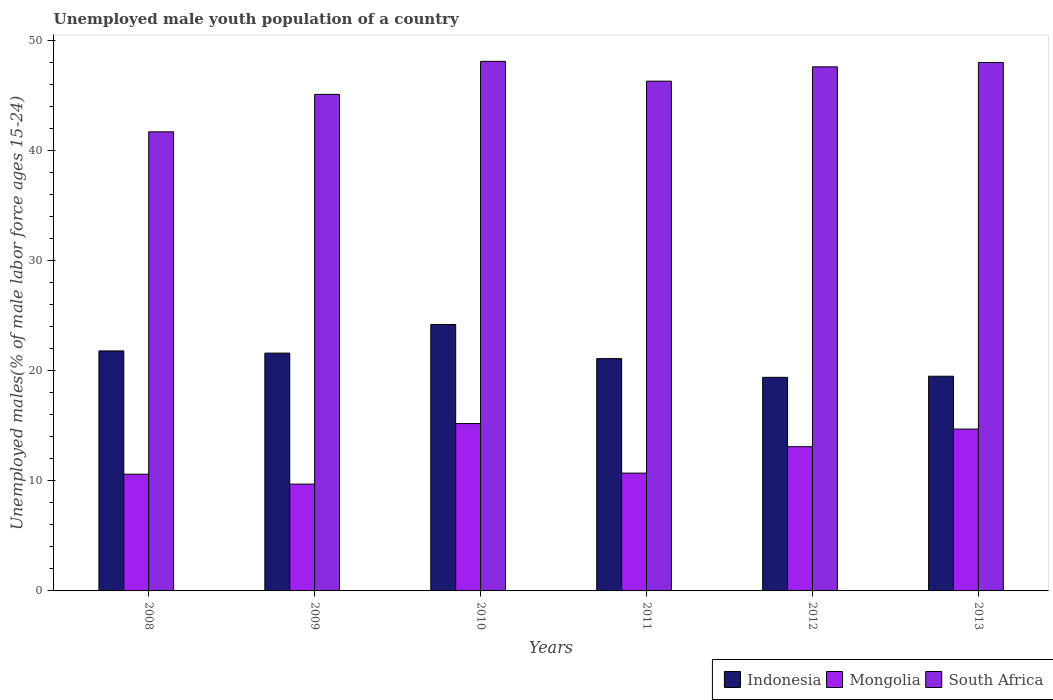How many different coloured bars are there?
Provide a short and direct response. 3. Are the number of bars on each tick of the X-axis equal?
Give a very brief answer. Yes. How many bars are there on the 6th tick from the right?
Provide a short and direct response. 3. What is the label of the 2nd group of bars from the left?
Offer a very short reply. 2009. What is the percentage of unemployed male youth population in Mongolia in 2010?
Ensure brevity in your answer.  15.2. Across all years, what is the maximum percentage of unemployed male youth population in South Africa?
Offer a very short reply. 48.1. Across all years, what is the minimum percentage of unemployed male youth population in Indonesia?
Make the answer very short. 19.4. In which year was the percentage of unemployed male youth population in Mongolia minimum?
Make the answer very short. 2009. What is the total percentage of unemployed male youth population in Indonesia in the graph?
Offer a terse response. 127.6. What is the difference between the percentage of unemployed male youth population in Indonesia in 2009 and that in 2013?
Your answer should be very brief. 2.1. What is the difference between the percentage of unemployed male youth population in South Africa in 2008 and the percentage of unemployed male youth population in Mongolia in 2011?
Your answer should be very brief. 31. What is the average percentage of unemployed male youth population in South Africa per year?
Provide a succinct answer. 46.13. In the year 2009, what is the difference between the percentage of unemployed male youth population in Indonesia and percentage of unemployed male youth population in Mongolia?
Your answer should be compact. 11.9. In how many years, is the percentage of unemployed male youth population in Indonesia greater than 32 %?
Keep it short and to the point. 0. What is the ratio of the percentage of unemployed male youth population in South Africa in 2008 to that in 2011?
Your response must be concise. 0.9. Is the percentage of unemployed male youth population in Indonesia in 2008 less than that in 2009?
Give a very brief answer. No. What is the difference between the highest and the second highest percentage of unemployed male youth population in Mongolia?
Your answer should be very brief. 0.5. What is the difference between the highest and the lowest percentage of unemployed male youth population in South Africa?
Offer a terse response. 6.4. What does the 2nd bar from the left in 2009 represents?
Give a very brief answer. Mongolia. What does the 2nd bar from the right in 2011 represents?
Offer a very short reply. Mongolia. How many bars are there?
Ensure brevity in your answer.  18. Are all the bars in the graph horizontal?
Your answer should be compact. No. How many years are there in the graph?
Your answer should be compact. 6. What is the difference between two consecutive major ticks on the Y-axis?
Give a very brief answer. 10. Are the values on the major ticks of Y-axis written in scientific E-notation?
Offer a terse response. No. Does the graph contain any zero values?
Offer a terse response. No. Does the graph contain grids?
Your answer should be very brief. No. How many legend labels are there?
Give a very brief answer. 3. How are the legend labels stacked?
Ensure brevity in your answer.  Horizontal. What is the title of the graph?
Ensure brevity in your answer.  Unemployed male youth population of a country. Does "Vietnam" appear as one of the legend labels in the graph?
Your answer should be very brief. No. What is the label or title of the X-axis?
Offer a very short reply. Years. What is the label or title of the Y-axis?
Offer a terse response. Unemployed males(% of male labor force ages 15-24). What is the Unemployed males(% of male labor force ages 15-24) of Indonesia in 2008?
Offer a very short reply. 21.8. What is the Unemployed males(% of male labor force ages 15-24) in Mongolia in 2008?
Provide a short and direct response. 10.6. What is the Unemployed males(% of male labor force ages 15-24) in South Africa in 2008?
Provide a succinct answer. 41.7. What is the Unemployed males(% of male labor force ages 15-24) in Indonesia in 2009?
Give a very brief answer. 21.6. What is the Unemployed males(% of male labor force ages 15-24) of Mongolia in 2009?
Provide a succinct answer. 9.7. What is the Unemployed males(% of male labor force ages 15-24) in South Africa in 2009?
Your answer should be compact. 45.1. What is the Unemployed males(% of male labor force ages 15-24) in Indonesia in 2010?
Give a very brief answer. 24.2. What is the Unemployed males(% of male labor force ages 15-24) of Mongolia in 2010?
Ensure brevity in your answer.  15.2. What is the Unemployed males(% of male labor force ages 15-24) of South Africa in 2010?
Your response must be concise. 48.1. What is the Unemployed males(% of male labor force ages 15-24) of Indonesia in 2011?
Keep it short and to the point. 21.1. What is the Unemployed males(% of male labor force ages 15-24) in Mongolia in 2011?
Make the answer very short. 10.7. What is the Unemployed males(% of male labor force ages 15-24) in South Africa in 2011?
Make the answer very short. 46.3. What is the Unemployed males(% of male labor force ages 15-24) in Indonesia in 2012?
Keep it short and to the point. 19.4. What is the Unemployed males(% of male labor force ages 15-24) in Mongolia in 2012?
Your answer should be compact. 13.1. What is the Unemployed males(% of male labor force ages 15-24) of South Africa in 2012?
Keep it short and to the point. 47.6. What is the Unemployed males(% of male labor force ages 15-24) of Indonesia in 2013?
Give a very brief answer. 19.5. What is the Unemployed males(% of male labor force ages 15-24) of Mongolia in 2013?
Make the answer very short. 14.7. Across all years, what is the maximum Unemployed males(% of male labor force ages 15-24) in Indonesia?
Give a very brief answer. 24.2. Across all years, what is the maximum Unemployed males(% of male labor force ages 15-24) in Mongolia?
Make the answer very short. 15.2. Across all years, what is the maximum Unemployed males(% of male labor force ages 15-24) of South Africa?
Give a very brief answer. 48.1. Across all years, what is the minimum Unemployed males(% of male labor force ages 15-24) in Indonesia?
Give a very brief answer. 19.4. Across all years, what is the minimum Unemployed males(% of male labor force ages 15-24) in Mongolia?
Offer a terse response. 9.7. Across all years, what is the minimum Unemployed males(% of male labor force ages 15-24) of South Africa?
Your response must be concise. 41.7. What is the total Unemployed males(% of male labor force ages 15-24) of Indonesia in the graph?
Give a very brief answer. 127.6. What is the total Unemployed males(% of male labor force ages 15-24) of South Africa in the graph?
Offer a very short reply. 276.8. What is the difference between the Unemployed males(% of male labor force ages 15-24) in Indonesia in 2008 and that in 2009?
Your response must be concise. 0.2. What is the difference between the Unemployed males(% of male labor force ages 15-24) of South Africa in 2008 and that in 2009?
Offer a terse response. -3.4. What is the difference between the Unemployed males(% of male labor force ages 15-24) in South Africa in 2008 and that in 2010?
Offer a very short reply. -6.4. What is the difference between the Unemployed males(% of male labor force ages 15-24) of Mongolia in 2008 and that in 2011?
Give a very brief answer. -0.1. What is the difference between the Unemployed males(% of male labor force ages 15-24) in Indonesia in 2008 and that in 2012?
Your answer should be compact. 2.4. What is the difference between the Unemployed males(% of male labor force ages 15-24) in Mongolia in 2008 and that in 2012?
Offer a terse response. -2.5. What is the difference between the Unemployed males(% of male labor force ages 15-24) in South Africa in 2008 and that in 2012?
Ensure brevity in your answer.  -5.9. What is the difference between the Unemployed males(% of male labor force ages 15-24) in Mongolia in 2008 and that in 2013?
Keep it short and to the point. -4.1. What is the difference between the Unemployed males(% of male labor force ages 15-24) in Indonesia in 2009 and that in 2010?
Offer a terse response. -2.6. What is the difference between the Unemployed males(% of male labor force ages 15-24) of Mongolia in 2009 and that in 2010?
Your response must be concise. -5.5. What is the difference between the Unemployed males(% of male labor force ages 15-24) in Mongolia in 2009 and that in 2011?
Provide a short and direct response. -1. What is the difference between the Unemployed males(% of male labor force ages 15-24) of South Africa in 2009 and that in 2011?
Make the answer very short. -1.2. What is the difference between the Unemployed males(% of male labor force ages 15-24) in South Africa in 2009 and that in 2012?
Provide a short and direct response. -2.5. What is the difference between the Unemployed males(% of male labor force ages 15-24) in Indonesia in 2009 and that in 2013?
Your answer should be compact. 2.1. What is the difference between the Unemployed males(% of male labor force ages 15-24) in Mongolia in 2009 and that in 2013?
Provide a succinct answer. -5. What is the difference between the Unemployed males(% of male labor force ages 15-24) in South Africa in 2009 and that in 2013?
Your answer should be very brief. -2.9. What is the difference between the Unemployed males(% of male labor force ages 15-24) of Mongolia in 2010 and that in 2011?
Provide a short and direct response. 4.5. What is the difference between the Unemployed males(% of male labor force ages 15-24) in South Africa in 2010 and that in 2011?
Give a very brief answer. 1.8. What is the difference between the Unemployed males(% of male labor force ages 15-24) in Indonesia in 2010 and that in 2012?
Your response must be concise. 4.8. What is the difference between the Unemployed males(% of male labor force ages 15-24) in Indonesia in 2010 and that in 2013?
Make the answer very short. 4.7. What is the difference between the Unemployed males(% of male labor force ages 15-24) of South Africa in 2010 and that in 2013?
Give a very brief answer. 0.1. What is the difference between the Unemployed males(% of male labor force ages 15-24) in Indonesia in 2011 and that in 2012?
Provide a succinct answer. 1.7. What is the difference between the Unemployed males(% of male labor force ages 15-24) in Mongolia in 2011 and that in 2012?
Your response must be concise. -2.4. What is the difference between the Unemployed males(% of male labor force ages 15-24) of South Africa in 2011 and that in 2012?
Your answer should be very brief. -1.3. What is the difference between the Unemployed males(% of male labor force ages 15-24) in Indonesia in 2011 and that in 2013?
Give a very brief answer. 1.6. What is the difference between the Unemployed males(% of male labor force ages 15-24) in Mongolia in 2011 and that in 2013?
Your answer should be compact. -4. What is the difference between the Unemployed males(% of male labor force ages 15-24) in Indonesia in 2008 and the Unemployed males(% of male labor force ages 15-24) in Mongolia in 2009?
Provide a succinct answer. 12.1. What is the difference between the Unemployed males(% of male labor force ages 15-24) in Indonesia in 2008 and the Unemployed males(% of male labor force ages 15-24) in South Africa in 2009?
Give a very brief answer. -23.3. What is the difference between the Unemployed males(% of male labor force ages 15-24) of Mongolia in 2008 and the Unemployed males(% of male labor force ages 15-24) of South Africa in 2009?
Make the answer very short. -34.5. What is the difference between the Unemployed males(% of male labor force ages 15-24) in Indonesia in 2008 and the Unemployed males(% of male labor force ages 15-24) in South Africa in 2010?
Your answer should be very brief. -26.3. What is the difference between the Unemployed males(% of male labor force ages 15-24) in Mongolia in 2008 and the Unemployed males(% of male labor force ages 15-24) in South Africa in 2010?
Provide a short and direct response. -37.5. What is the difference between the Unemployed males(% of male labor force ages 15-24) of Indonesia in 2008 and the Unemployed males(% of male labor force ages 15-24) of Mongolia in 2011?
Offer a terse response. 11.1. What is the difference between the Unemployed males(% of male labor force ages 15-24) in Indonesia in 2008 and the Unemployed males(% of male labor force ages 15-24) in South Africa in 2011?
Provide a succinct answer. -24.5. What is the difference between the Unemployed males(% of male labor force ages 15-24) of Mongolia in 2008 and the Unemployed males(% of male labor force ages 15-24) of South Africa in 2011?
Make the answer very short. -35.7. What is the difference between the Unemployed males(% of male labor force ages 15-24) of Indonesia in 2008 and the Unemployed males(% of male labor force ages 15-24) of Mongolia in 2012?
Ensure brevity in your answer.  8.7. What is the difference between the Unemployed males(% of male labor force ages 15-24) of Indonesia in 2008 and the Unemployed males(% of male labor force ages 15-24) of South Africa in 2012?
Give a very brief answer. -25.8. What is the difference between the Unemployed males(% of male labor force ages 15-24) of Mongolia in 2008 and the Unemployed males(% of male labor force ages 15-24) of South Africa in 2012?
Provide a succinct answer. -37. What is the difference between the Unemployed males(% of male labor force ages 15-24) of Indonesia in 2008 and the Unemployed males(% of male labor force ages 15-24) of South Africa in 2013?
Provide a succinct answer. -26.2. What is the difference between the Unemployed males(% of male labor force ages 15-24) in Mongolia in 2008 and the Unemployed males(% of male labor force ages 15-24) in South Africa in 2013?
Your answer should be compact. -37.4. What is the difference between the Unemployed males(% of male labor force ages 15-24) of Indonesia in 2009 and the Unemployed males(% of male labor force ages 15-24) of Mongolia in 2010?
Keep it short and to the point. 6.4. What is the difference between the Unemployed males(% of male labor force ages 15-24) of Indonesia in 2009 and the Unemployed males(% of male labor force ages 15-24) of South Africa in 2010?
Provide a succinct answer. -26.5. What is the difference between the Unemployed males(% of male labor force ages 15-24) in Mongolia in 2009 and the Unemployed males(% of male labor force ages 15-24) in South Africa in 2010?
Make the answer very short. -38.4. What is the difference between the Unemployed males(% of male labor force ages 15-24) in Indonesia in 2009 and the Unemployed males(% of male labor force ages 15-24) in South Africa in 2011?
Your response must be concise. -24.7. What is the difference between the Unemployed males(% of male labor force ages 15-24) of Mongolia in 2009 and the Unemployed males(% of male labor force ages 15-24) of South Africa in 2011?
Your answer should be compact. -36.6. What is the difference between the Unemployed males(% of male labor force ages 15-24) of Mongolia in 2009 and the Unemployed males(% of male labor force ages 15-24) of South Africa in 2012?
Your response must be concise. -37.9. What is the difference between the Unemployed males(% of male labor force ages 15-24) of Indonesia in 2009 and the Unemployed males(% of male labor force ages 15-24) of South Africa in 2013?
Keep it short and to the point. -26.4. What is the difference between the Unemployed males(% of male labor force ages 15-24) of Mongolia in 2009 and the Unemployed males(% of male labor force ages 15-24) of South Africa in 2013?
Your answer should be compact. -38.3. What is the difference between the Unemployed males(% of male labor force ages 15-24) of Indonesia in 2010 and the Unemployed males(% of male labor force ages 15-24) of Mongolia in 2011?
Provide a succinct answer. 13.5. What is the difference between the Unemployed males(% of male labor force ages 15-24) in Indonesia in 2010 and the Unemployed males(% of male labor force ages 15-24) in South Africa in 2011?
Offer a very short reply. -22.1. What is the difference between the Unemployed males(% of male labor force ages 15-24) in Mongolia in 2010 and the Unemployed males(% of male labor force ages 15-24) in South Africa in 2011?
Keep it short and to the point. -31.1. What is the difference between the Unemployed males(% of male labor force ages 15-24) in Indonesia in 2010 and the Unemployed males(% of male labor force ages 15-24) in South Africa in 2012?
Provide a short and direct response. -23.4. What is the difference between the Unemployed males(% of male labor force ages 15-24) in Mongolia in 2010 and the Unemployed males(% of male labor force ages 15-24) in South Africa in 2012?
Keep it short and to the point. -32.4. What is the difference between the Unemployed males(% of male labor force ages 15-24) of Indonesia in 2010 and the Unemployed males(% of male labor force ages 15-24) of South Africa in 2013?
Make the answer very short. -23.8. What is the difference between the Unemployed males(% of male labor force ages 15-24) of Mongolia in 2010 and the Unemployed males(% of male labor force ages 15-24) of South Africa in 2013?
Provide a succinct answer. -32.8. What is the difference between the Unemployed males(% of male labor force ages 15-24) in Indonesia in 2011 and the Unemployed males(% of male labor force ages 15-24) in South Africa in 2012?
Provide a succinct answer. -26.5. What is the difference between the Unemployed males(% of male labor force ages 15-24) in Mongolia in 2011 and the Unemployed males(% of male labor force ages 15-24) in South Africa in 2012?
Offer a very short reply. -36.9. What is the difference between the Unemployed males(% of male labor force ages 15-24) of Indonesia in 2011 and the Unemployed males(% of male labor force ages 15-24) of South Africa in 2013?
Offer a very short reply. -26.9. What is the difference between the Unemployed males(% of male labor force ages 15-24) in Mongolia in 2011 and the Unemployed males(% of male labor force ages 15-24) in South Africa in 2013?
Provide a short and direct response. -37.3. What is the difference between the Unemployed males(% of male labor force ages 15-24) of Indonesia in 2012 and the Unemployed males(% of male labor force ages 15-24) of Mongolia in 2013?
Your answer should be very brief. 4.7. What is the difference between the Unemployed males(% of male labor force ages 15-24) of Indonesia in 2012 and the Unemployed males(% of male labor force ages 15-24) of South Africa in 2013?
Ensure brevity in your answer.  -28.6. What is the difference between the Unemployed males(% of male labor force ages 15-24) in Mongolia in 2012 and the Unemployed males(% of male labor force ages 15-24) in South Africa in 2013?
Provide a short and direct response. -34.9. What is the average Unemployed males(% of male labor force ages 15-24) in Indonesia per year?
Provide a succinct answer. 21.27. What is the average Unemployed males(% of male labor force ages 15-24) in Mongolia per year?
Offer a terse response. 12.33. What is the average Unemployed males(% of male labor force ages 15-24) in South Africa per year?
Give a very brief answer. 46.13. In the year 2008, what is the difference between the Unemployed males(% of male labor force ages 15-24) in Indonesia and Unemployed males(% of male labor force ages 15-24) in Mongolia?
Your response must be concise. 11.2. In the year 2008, what is the difference between the Unemployed males(% of male labor force ages 15-24) of Indonesia and Unemployed males(% of male labor force ages 15-24) of South Africa?
Make the answer very short. -19.9. In the year 2008, what is the difference between the Unemployed males(% of male labor force ages 15-24) of Mongolia and Unemployed males(% of male labor force ages 15-24) of South Africa?
Provide a short and direct response. -31.1. In the year 2009, what is the difference between the Unemployed males(% of male labor force ages 15-24) in Indonesia and Unemployed males(% of male labor force ages 15-24) in South Africa?
Make the answer very short. -23.5. In the year 2009, what is the difference between the Unemployed males(% of male labor force ages 15-24) of Mongolia and Unemployed males(% of male labor force ages 15-24) of South Africa?
Your answer should be very brief. -35.4. In the year 2010, what is the difference between the Unemployed males(% of male labor force ages 15-24) in Indonesia and Unemployed males(% of male labor force ages 15-24) in Mongolia?
Keep it short and to the point. 9. In the year 2010, what is the difference between the Unemployed males(% of male labor force ages 15-24) in Indonesia and Unemployed males(% of male labor force ages 15-24) in South Africa?
Give a very brief answer. -23.9. In the year 2010, what is the difference between the Unemployed males(% of male labor force ages 15-24) of Mongolia and Unemployed males(% of male labor force ages 15-24) of South Africa?
Give a very brief answer. -32.9. In the year 2011, what is the difference between the Unemployed males(% of male labor force ages 15-24) of Indonesia and Unemployed males(% of male labor force ages 15-24) of Mongolia?
Provide a succinct answer. 10.4. In the year 2011, what is the difference between the Unemployed males(% of male labor force ages 15-24) of Indonesia and Unemployed males(% of male labor force ages 15-24) of South Africa?
Your answer should be compact. -25.2. In the year 2011, what is the difference between the Unemployed males(% of male labor force ages 15-24) of Mongolia and Unemployed males(% of male labor force ages 15-24) of South Africa?
Your answer should be very brief. -35.6. In the year 2012, what is the difference between the Unemployed males(% of male labor force ages 15-24) in Indonesia and Unemployed males(% of male labor force ages 15-24) in South Africa?
Your answer should be very brief. -28.2. In the year 2012, what is the difference between the Unemployed males(% of male labor force ages 15-24) of Mongolia and Unemployed males(% of male labor force ages 15-24) of South Africa?
Provide a short and direct response. -34.5. In the year 2013, what is the difference between the Unemployed males(% of male labor force ages 15-24) of Indonesia and Unemployed males(% of male labor force ages 15-24) of Mongolia?
Offer a terse response. 4.8. In the year 2013, what is the difference between the Unemployed males(% of male labor force ages 15-24) of Indonesia and Unemployed males(% of male labor force ages 15-24) of South Africa?
Keep it short and to the point. -28.5. In the year 2013, what is the difference between the Unemployed males(% of male labor force ages 15-24) in Mongolia and Unemployed males(% of male labor force ages 15-24) in South Africa?
Offer a very short reply. -33.3. What is the ratio of the Unemployed males(% of male labor force ages 15-24) in Indonesia in 2008 to that in 2009?
Give a very brief answer. 1.01. What is the ratio of the Unemployed males(% of male labor force ages 15-24) in Mongolia in 2008 to that in 2009?
Your answer should be compact. 1.09. What is the ratio of the Unemployed males(% of male labor force ages 15-24) in South Africa in 2008 to that in 2009?
Ensure brevity in your answer.  0.92. What is the ratio of the Unemployed males(% of male labor force ages 15-24) in Indonesia in 2008 to that in 2010?
Offer a very short reply. 0.9. What is the ratio of the Unemployed males(% of male labor force ages 15-24) in Mongolia in 2008 to that in 2010?
Offer a terse response. 0.7. What is the ratio of the Unemployed males(% of male labor force ages 15-24) in South Africa in 2008 to that in 2010?
Offer a very short reply. 0.87. What is the ratio of the Unemployed males(% of male labor force ages 15-24) of Indonesia in 2008 to that in 2011?
Offer a terse response. 1.03. What is the ratio of the Unemployed males(% of male labor force ages 15-24) of Mongolia in 2008 to that in 2011?
Offer a terse response. 0.99. What is the ratio of the Unemployed males(% of male labor force ages 15-24) of South Africa in 2008 to that in 2011?
Provide a short and direct response. 0.9. What is the ratio of the Unemployed males(% of male labor force ages 15-24) of Indonesia in 2008 to that in 2012?
Keep it short and to the point. 1.12. What is the ratio of the Unemployed males(% of male labor force ages 15-24) of Mongolia in 2008 to that in 2012?
Your answer should be compact. 0.81. What is the ratio of the Unemployed males(% of male labor force ages 15-24) of South Africa in 2008 to that in 2012?
Keep it short and to the point. 0.88. What is the ratio of the Unemployed males(% of male labor force ages 15-24) in Indonesia in 2008 to that in 2013?
Offer a very short reply. 1.12. What is the ratio of the Unemployed males(% of male labor force ages 15-24) in Mongolia in 2008 to that in 2013?
Your answer should be very brief. 0.72. What is the ratio of the Unemployed males(% of male labor force ages 15-24) of South Africa in 2008 to that in 2013?
Make the answer very short. 0.87. What is the ratio of the Unemployed males(% of male labor force ages 15-24) in Indonesia in 2009 to that in 2010?
Provide a succinct answer. 0.89. What is the ratio of the Unemployed males(% of male labor force ages 15-24) of Mongolia in 2009 to that in 2010?
Offer a very short reply. 0.64. What is the ratio of the Unemployed males(% of male labor force ages 15-24) of South Africa in 2009 to that in 2010?
Give a very brief answer. 0.94. What is the ratio of the Unemployed males(% of male labor force ages 15-24) of Indonesia in 2009 to that in 2011?
Ensure brevity in your answer.  1.02. What is the ratio of the Unemployed males(% of male labor force ages 15-24) of Mongolia in 2009 to that in 2011?
Your answer should be very brief. 0.91. What is the ratio of the Unemployed males(% of male labor force ages 15-24) in South Africa in 2009 to that in 2011?
Your answer should be compact. 0.97. What is the ratio of the Unemployed males(% of male labor force ages 15-24) in Indonesia in 2009 to that in 2012?
Provide a short and direct response. 1.11. What is the ratio of the Unemployed males(% of male labor force ages 15-24) in Mongolia in 2009 to that in 2012?
Your answer should be compact. 0.74. What is the ratio of the Unemployed males(% of male labor force ages 15-24) in South Africa in 2009 to that in 2012?
Make the answer very short. 0.95. What is the ratio of the Unemployed males(% of male labor force ages 15-24) in Indonesia in 2009 to that in 2013?
Provide a succinct answer. 1.11. What is the ratio of the Unemployed males(% of male labor force ages 15-24) in Mongolia in 2009 to that in 2013?
Your response must be concise. 0.66. What is the ratio of the Unemployed males(% of male labor force ages 15-24) of South Africa in 2009 to that in 2013?
Offer a terse response. 0.94. What is the ratio of the Unemployed males(% of male labor force ages 15-24) in Indonesia in 2010 to that in 2011?
Your answer should be compact. 1.15. What is the ratio of the Unemployed males(% of male labor force ages 15-24) of Mongolia in 2010 to that in 2011?
Provide a succinct answer. 1.42. What is the ratio of the Unemployed males(% of male labor force ages 15-24) of South Africa in 2010 to that in 2011?
Keep it short and to the point. 1.04. What is the ratio of the Unemployed males(% of male labor force ages 15-24) of Indonesia in 2010 to that in 2012?
Ensure brevity in your answer.  1.25. What is the ratio of the Unemployed males(% of male labor force ages 15-24) of Mongolia in 2010 to that in 2012?
Make the answer very short. 1.16. What is the ratio of the Unemployed males(% of male labor force ages 15-24) of South Africa in 2010 to that in 2012?
Make the answer very short. 1.01. What is the ratio of the Unemployed males(% of male labor force ages 15-24) in Indonesia in 2010 to that in 2013?
Offer a very short reply. 1.24. What is the ratio of the Unemployed males(% of male labor force ages 15-24) of Mongolia in 2010 to that in 2013?
Provide a succinct answer. 1.03. What is the ratio of the Unemployed males(% of male labor force ages 15-24) of South Africa in 2010 to that in 2013?
Ensure brevity in your answer.  1. What is the ratio of the Unemployed males(% of male labor force ages 15-24) in Indonesia in 2011 to that in 2012?
Keep it short and to the point. 1.09. What is the ratio of the Unemployed males(% of male labor force ages 15-24) in Mongolia in 2011 to that in 2012?
Make the answer very short. 0.82. What is the ratio of the Unemployed males(% of male labor force ages 15-24) of South Africa in 2011 to that in 2012?
Offer a very short reply. 0.97. What is the ratio of the Unemployed males(% of male labor force ages 15-24) of Indonesia in 2011 to that in 2013?
Keep it short and to the point. 1.08. What is the ratio of the Unemployed males(% of male labor force ages 15-24) of Mongolia in 2011 to that in 2013?
Your answer should be compact. 0.73. What is the ratio of the Unemployed males(% of male labor force ages 15-24) of South Africa in 2011 to that in 2013?
Your answer should be compact. 0.96. What is the ratio of the Unemployed males(% of male labor force ages 15-24) in Indonesia in 2012 to that in 2013?
Provide a succinct answer. 0.99. What is the ratio of the Unemployed males(% of male labor force ages 15-24) of Mongolia in 2012 to that in 2013?
Your response must be concise. 0.89. What is the ratio of the Unemployed males(% of male labor force ages 15-24) of South Africa in 2012 to that in 2013?
Provide a succinct answer. 0.99. What is the difference between the highest and the second highest Unemployed males(% of male labor force ages 15-24) in Mongolia?
Your response must be concise. 0.5. What is the difference between the highest and the second highest Unemployed males(% of male labor force ages 15-24) of South Africa?
Give a very brief answer. 0.1. What is the difference between the highest and the lowest Unemployed males(% of male labor force ages 15-24) of Mongolia?
Offer a terse response. 5.5. What is the difference between the highest and the lowest Unemployed males(% of male labor force ages 15-24) in South Africa?
Your answer should be compact. 6.4. 